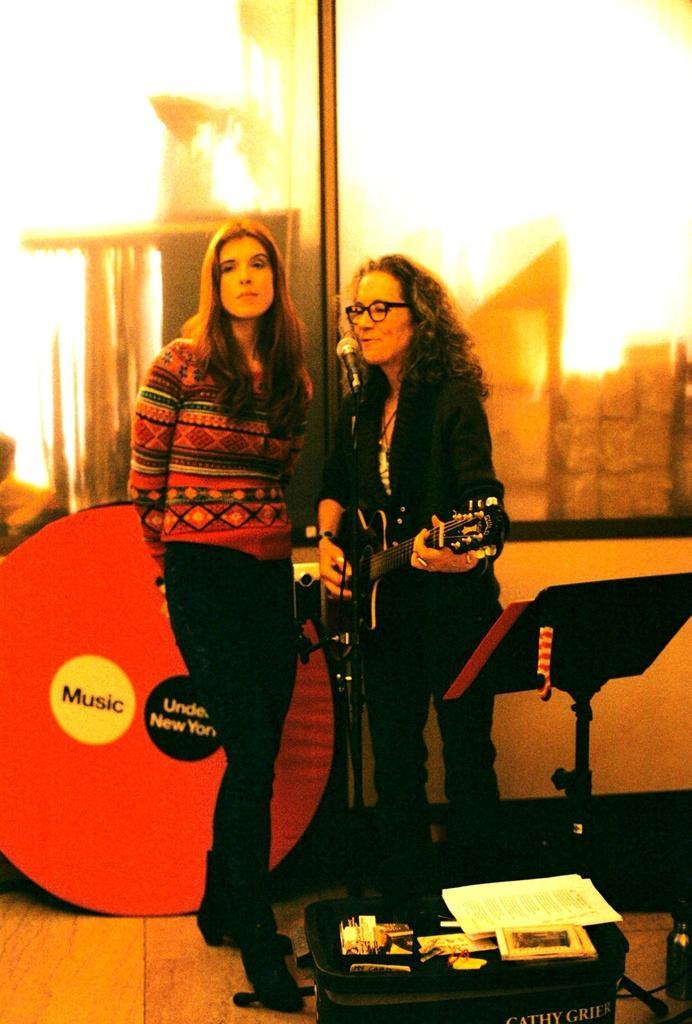Describe this image in one or two sentences. There are two women standing in the middle of this image, and there is a glass wall in the background. There is a Mic as we can see in the middle of this image. There are papers and some other objects are kept on a table at the bottom of this image. 